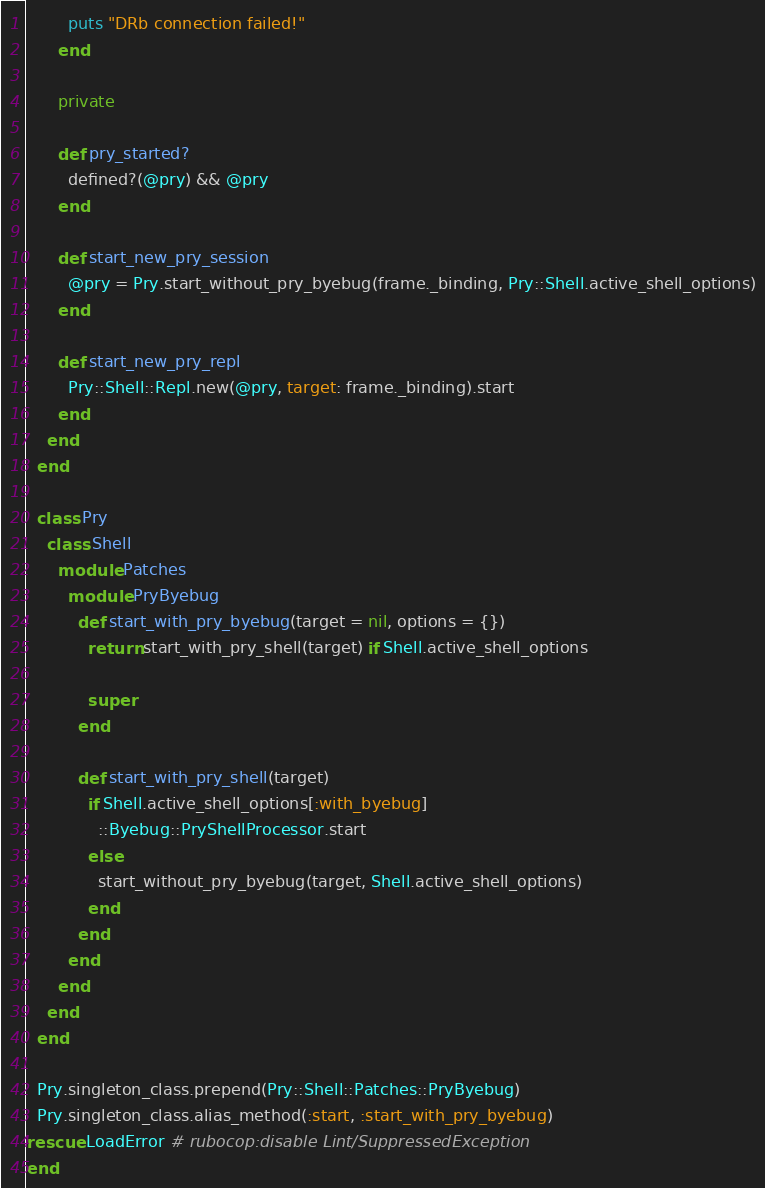Convert code to text. <code><loc_0><loc_0><loc_500><loc_500><_Ruby_>        puts "DRb connection failed!"
      end

      private

      def pry_started?
        defined?(@pry) && @pry
      end

      def start_new_pry_session
        @pry = Pry.start_without_pry_byebug(frame._binding, Pry::Shell.active_shell_options)
      end

      def start_new_pry_repl
        Pry::Shell::Repl.new(@pry, target: frame._binding).start
      end
    end
  end

  class Pry
    class Shell
      module Patches
        module PryByebug
          def start_with_pry_byebug(target = nil, options = {})
            return start_with_pry_shell(target) if Shell.active_shell_options

            super
          end

          def start_with_pry_shell(target)
            if Shell.active_shell_options[:with_byebug]
              ::Byebug::PryShellProcessor.start
            else
              start_without_pry_byebug(target, Shell.active_shell_options)
            end
          end
        end
      end
    end
  end

  Pry.singleton_class.prepend(Pry::Shell::Patches::PryByebug)
  Pry.singleton_class.alias_method(:start, :start_with_pry_byebug)
rescue LoadError # rubocop:disable Lint/SuppressedException
end
</code> 